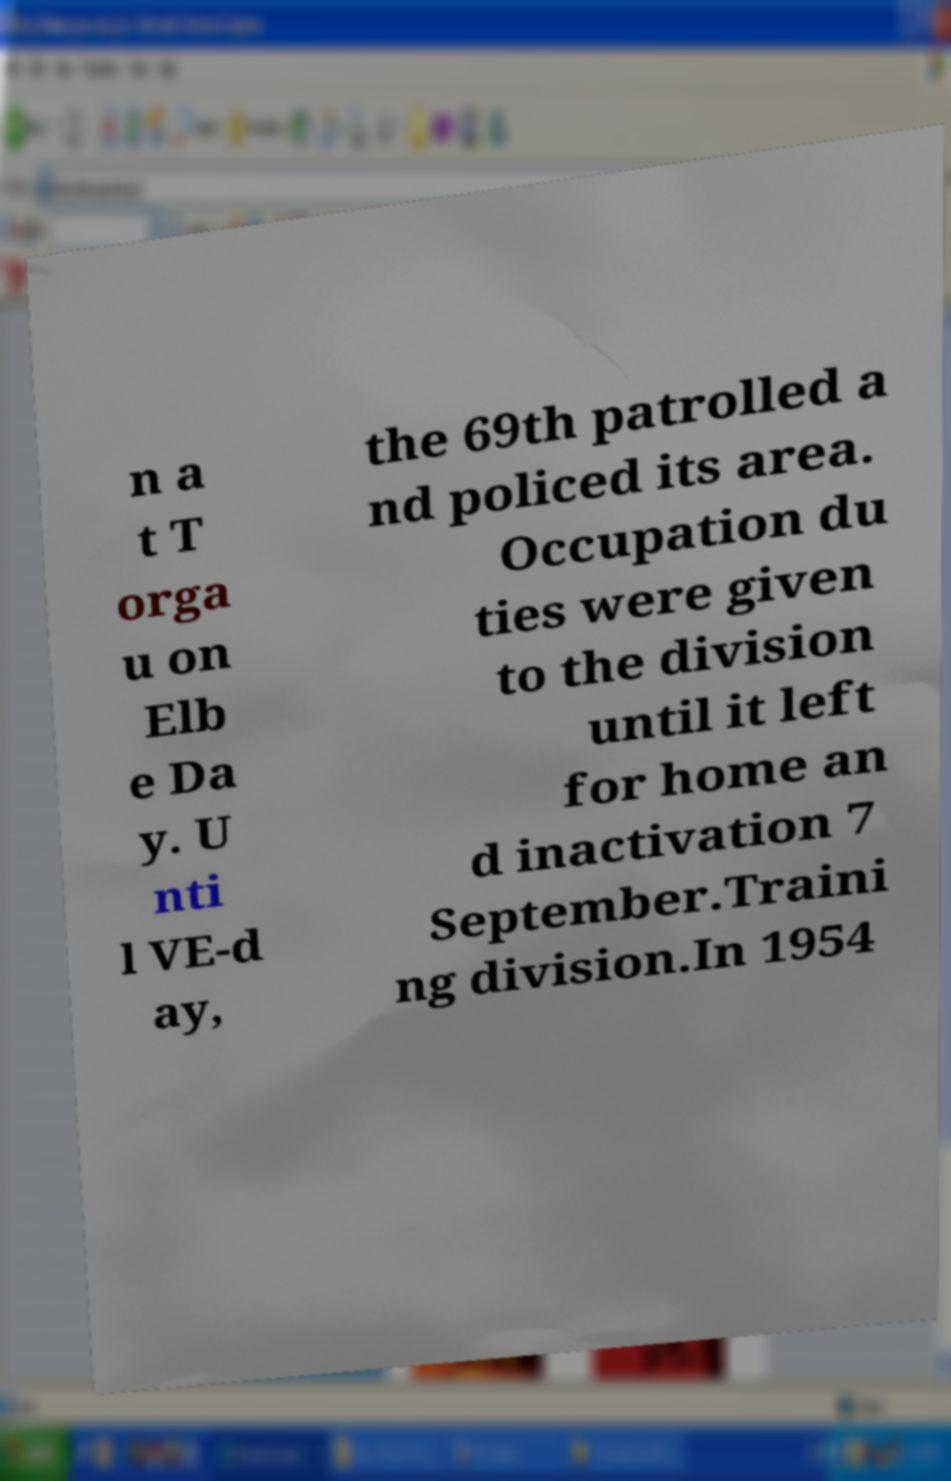For documentation purposes, I need the text within this image transcribed. Could you provide that? n a t T orga u on Elb e Da y. U nti l VE-d ay, the 69th patrolled a nd policed its area. Occupation du ties were given to the division until it left for home an d inactivation 7 September.Traini ng division.In 1954 